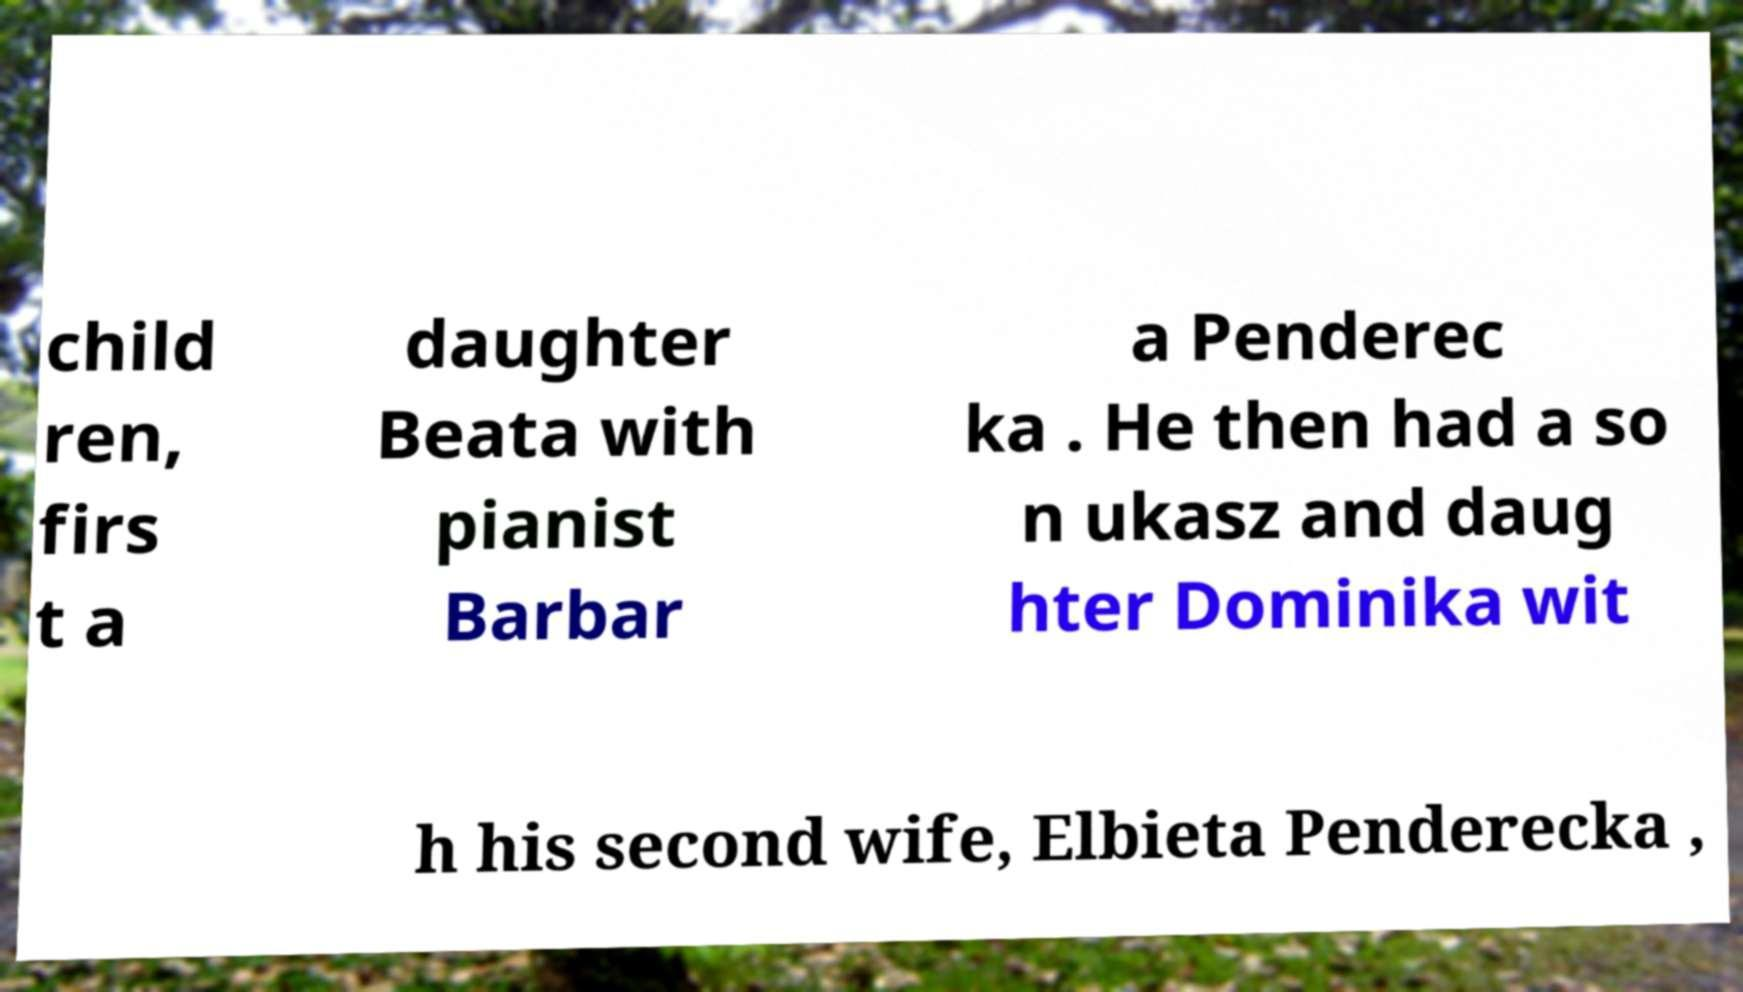Please identify and transcribe the text found in this image. child ren, firs t a daughter Beata with pianist Barbar a Penderec ka . He then had a so n ukasz and daug hter Dominika wit h his second wife, Elbieta Penderecka , 